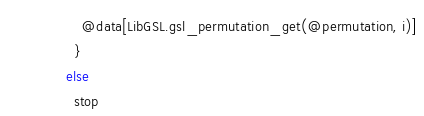Convert code to text. <code><loc_0><loc_0><loc_500><loc_500><_Crystal_>          @data[LibGSL.gsl_permutation_get(@permutation, i)]
        }
      else
        stop</code> 